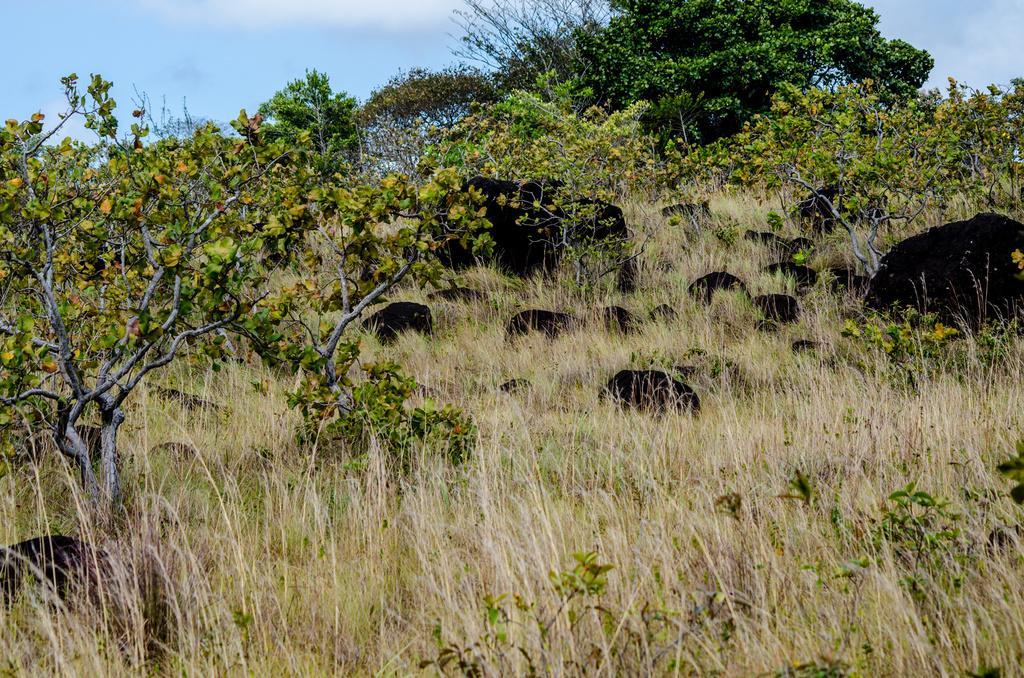Can you describe this image briefly? This image consists of a forest. At the bottom, there is grass. In the background, there are trees. In the middle, there are rocks. At the top, there is sky. 